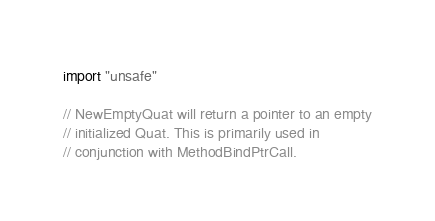<code> <loc_0><loc_0><loc_500><loc_500><_Go_>import "unsafe"

// NewEmptyQuat will return a pointer to an empty
// initialized Quat. This is primarily used in
// conjunction with MethodBindPtrCall.</code> 